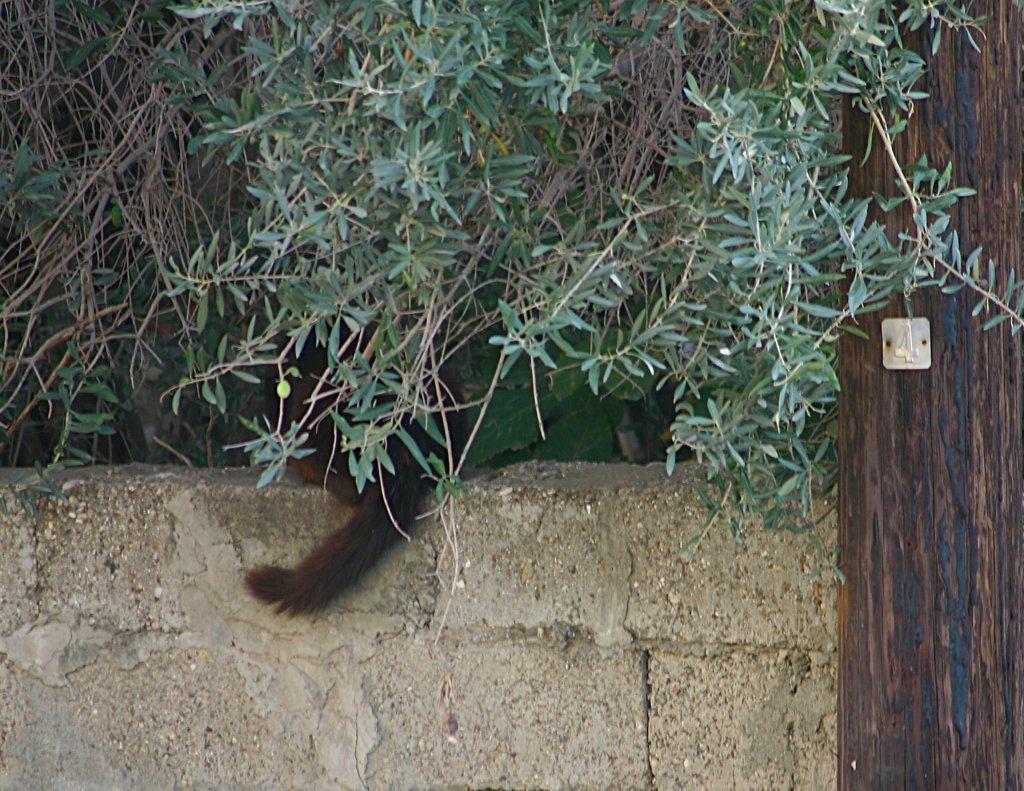Please provide a concise description of this image. In this image I can see a wall, background I can see trees in green color. I can also see an animal in brown color sitting on the wall. 